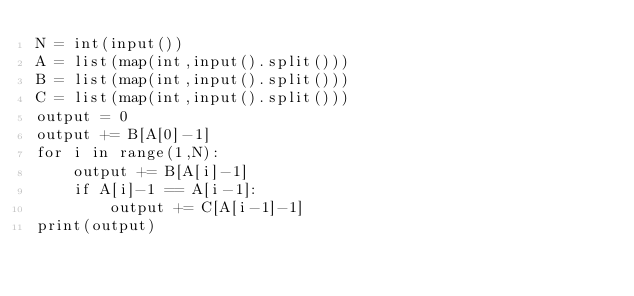Convert code to text. <code><loc_0><loc_0><loc_500><loc_500><_Python_>N = int(input())
A = list(map(int,input().split()))
B = list(map(int,input().split()))
C = list(map(int,input().split()))
output = 0
output += B[A[0]-1]
for i in range(1,N):
    output += B[A[i]-1]
    if A[i]-1 == A[i-1]:
        output += C[A[i-1]-1]
print(output)
</code> 